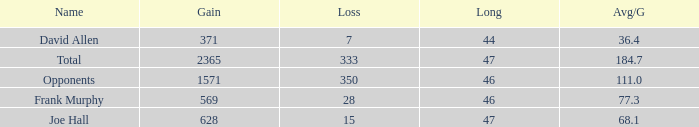How much Loss has a Gain smaller than 1571, and a Long smaller than 47, and an Avg/G of 36.4? 1.0. 